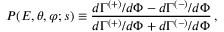<formula> <loc_0><loc_0><loc_500><loc_500>P ( E , \theta , \varphi ; s ) \equiv \frac { d \Gamma ^ { ( + ) } / d \Phi - d \Gamma ^ { ( - ) } / d \Phi } { d \Gamma ^ { ( + ) } / d \Phi + d \Gamma ^ { ( - ) } / d \Phi } \, ,</formula> 